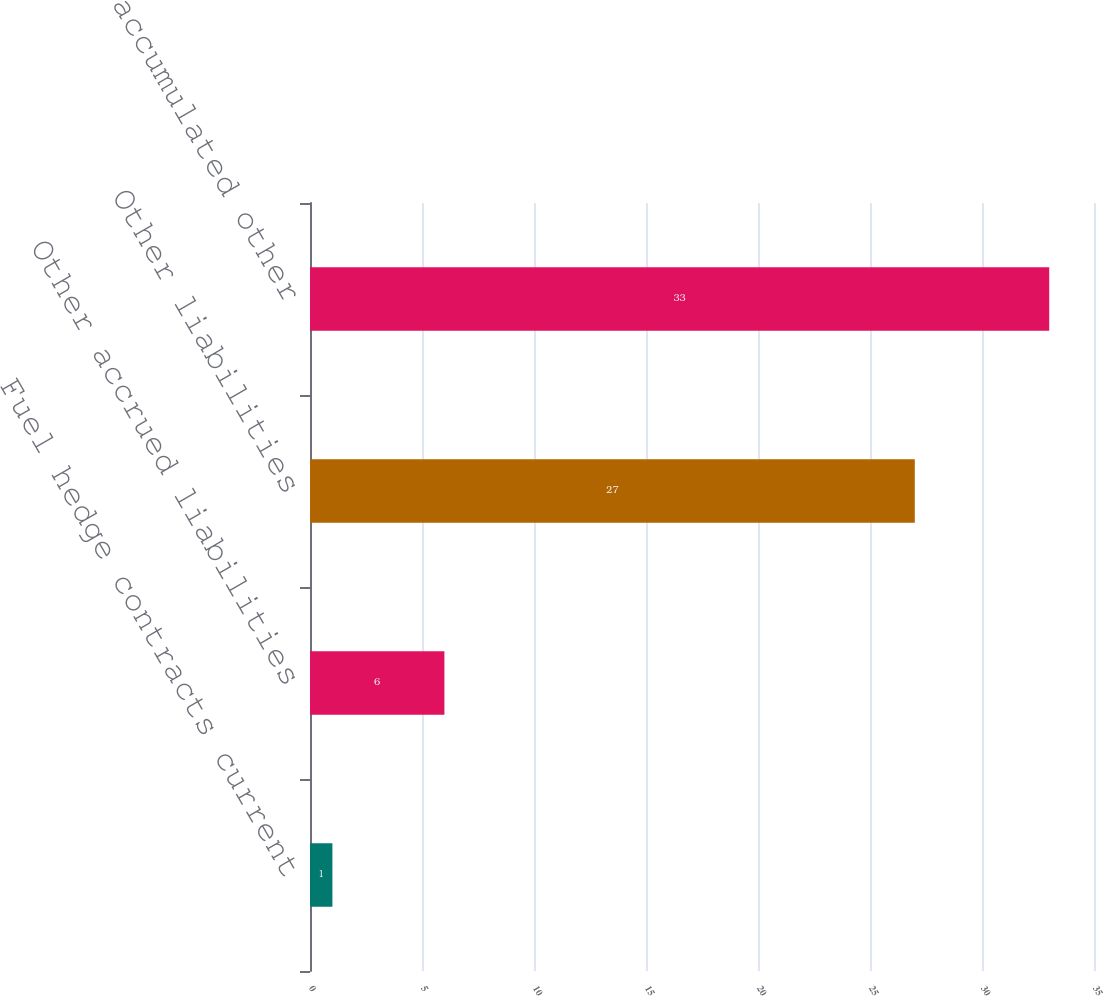Convert chart. <chart><loc_0><loc_0><loc_500><loc_500><bar_chart><fcel>Fuel hedge contracts current<fcel>Other accrued liabilities<fcel>Other liabilities<fcel>Losses in accumulated other<nl><fcel>1<fcel>6<fcel>27<fcel>33<nl></chart> 